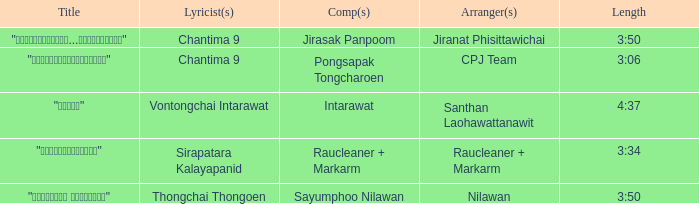Who was the arranger for the song that had a lyricist of Sirapatara Kalayapanid? Raucleaner + Markarm. 